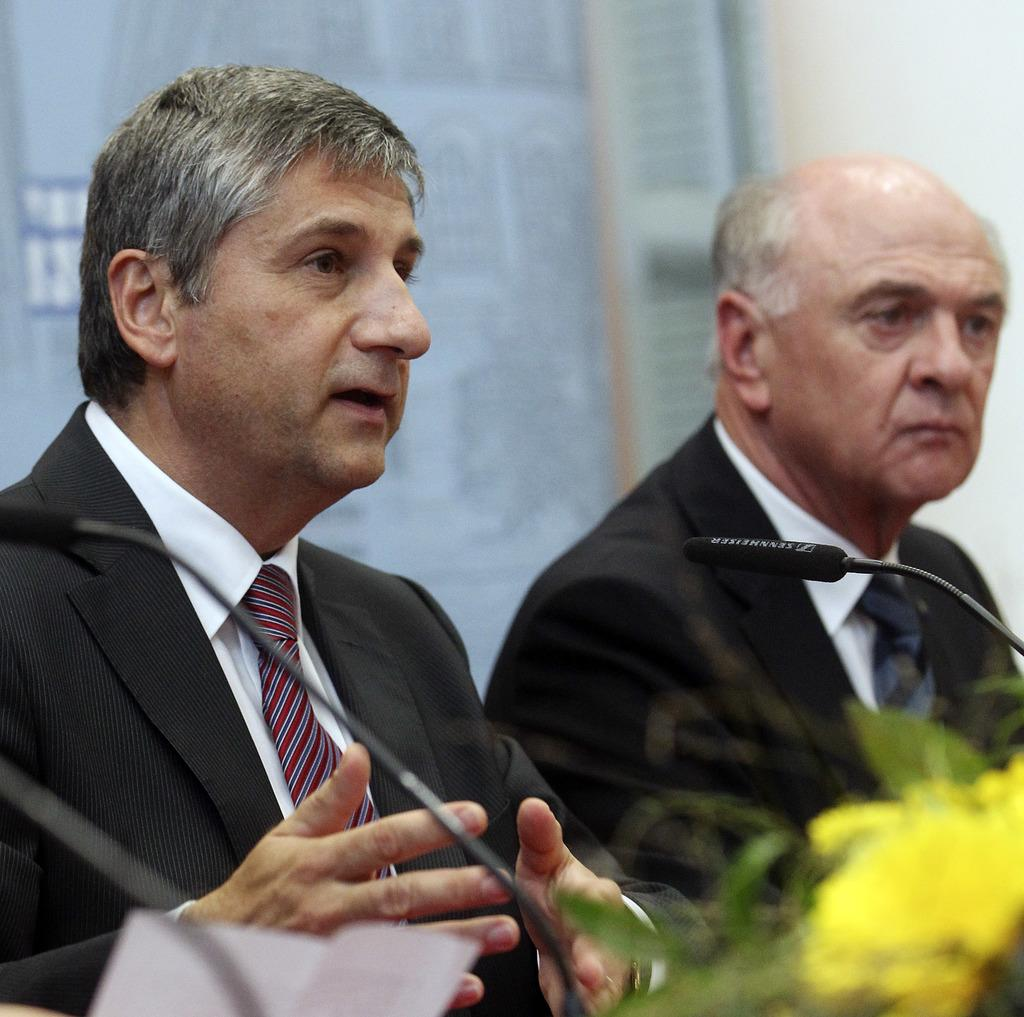How many people are present in the image? There are two men in the image. What object can be seen in the image that might be used for communication? There are mics with stands in the image. What type of plant is visible in the image? There is a plant with a flower in the image. What is on the wall in the background of the image? There is a board on a wall in the background of the image. What type of authority does the secretary have in the image? There is no secretary present in the image, so it is not possible to determine the type of authority they might have. 